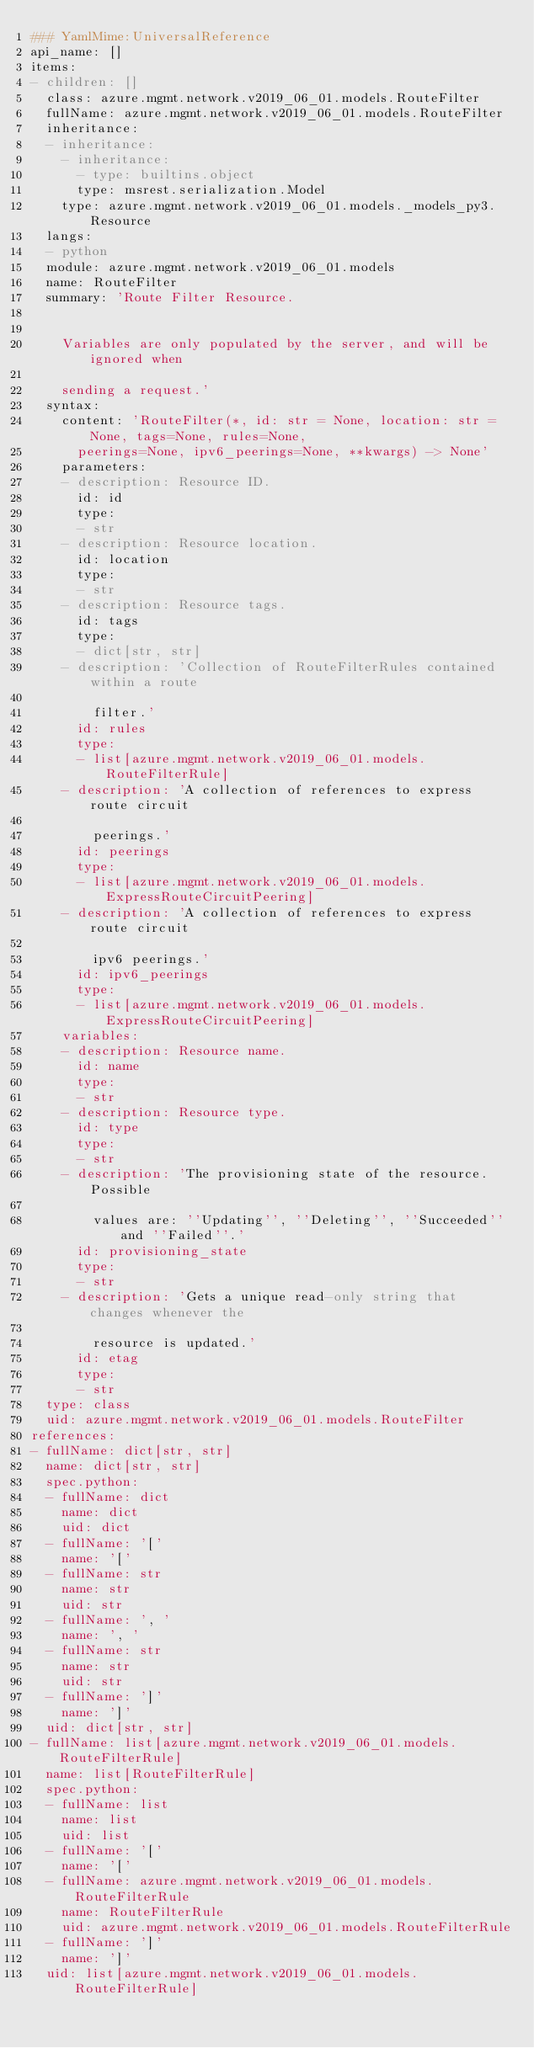Convert code to text. <code><loc_0><loc_0><loc_500><loc_500><_YAML_>### YamlMime:UniversalReference
api_name: []
items:
- children: []
  class: azure.mgmt.network.v2019_06_01.models.RouteFilter
  fullName: azure.mgmt.network.v2019_06_01.models.RouteFilter
  inheritance:
  - inheritance:
    - inheritance:
      - type: builtins.object
      type: msrest.serialization.Model
    type: azure.mgmt.network.v2019_06_01.models._models_py3.Resource
  langs:
  - python
  module: azure.mgmt.network.v2019_06_01.models
  name: RouteFilter
  summary: 'Route Filter Resource.


    Variables are only populated by the server, and will be ignored when

    sending a request.'
  syntax:
    content: 'RouteFilter(*, id: str = None, location: str = None, tags=None, rules=None,
      peerings=None, ipv6_peerings=None, **kwargs) -> None'
    parameters:
    - description: Resource ID.
      id: id
      type:
      - str
    - description: Resource location.
      id: location
      type:
      - str
    - description: Resource tags.
      id: tags
      type:
      - dict[str, str]
    - description: 'Collection of RouteFilterRules contained within a route

        filter.'
      id: rules
      type:
      - list[azure.mgmt.network.v2019_06_01.models.RouteFilterRule]
    - description: 'A collection of references to express route circuit

        peerings.'
      id: peerings
      type:
      - list[azure.mgmt.network.v2019_06_01.models.ExpressRouteCircuitPeering]
    - description: 'A collection of references to express route circuit

        ipv6 peerings.'
      id: ipv6_peerings
      type:
      - list[azure.mgmt.network.v2019_06_01.models.ExpressRouteCircuitPeering]
    variables:
    - description: Resource name.
      id: name
      type:
      - str
    - description: Resource type.
      id: type
      type:
      - str
    - description: 'The provisioning state of the resource. Possible

        values are: ''Updating'', ''Deleting'', ''Succeeded'' and ''Failed''.'
      id: provisioning_state
      type:
      - str
    - description: 'Gets a unique read-only string that changes whenever the

        resource is updated.'
      id: etag
      type:
      - str
  type: class
  uid: azure.mgmt.network.v2019_06_01.models.RouteFilter
references:
- fullName: dict[str, str]
  name: dict[str, str]
  spec.python:
  - fullName: dict
    name: dict
    uid: dict
  - fullName: '['
    name: '['
  - fullName: str
    name: str
    uid: str
  - fullName: ', '
    name: ', '
  - fullName: str
    name: str
    uid: str
  - fullName: ']'
    name: ']'
  uid: dict[str, str]
- fullName: list[azure.mgmt.network.v2019_06_01.models.RouteFilterRule]
  name: list[RouteFilterRule]
  spec.python:
  - fullName: list
    name: list
    uid: list
  - fullName: '['
    name: '['
  - fullName: azure.mgmt.network.v2019_06_01.models.RouteFilterRule
    name: RouteFilterRule
    uid: azure.mgmt.network.v2019_06_01.models.RouteFilterRule
  - fullName: ']'
    name: ']'
  uid: list[azure.mgmt.network.v2019_06_01.models.RouteFilterRule]</code> 